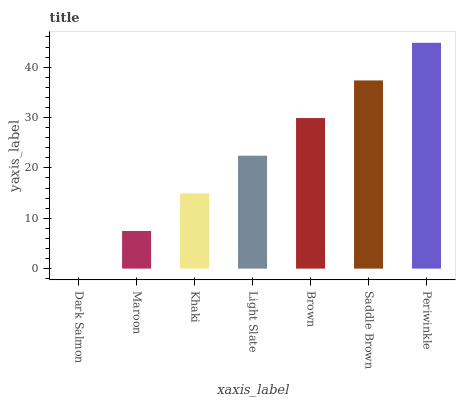Is Maroon the minimum?
Answer yes or no. No. Is Maroon the maximum?
Answer yes or no. No. Is Maroon greater than Dark Salmon?
Answer yes or no. Yes. Is Dark Salmon less than Maroon?
Answer yes or no. Yes. Is Dark Salmon greater than Maroon?
Answer yes or no. No. Is Maroon less than Dark Salmon?
Answer yes or no. No. Is Light Slate the high median?
Answer yes or no. Yes. Is Light Slate the low median?
Answer yes or no. Yes. Is Saddle Brown the high median?
Answer yes or no. No. Is Brown the low median?
Answer yes or no. No. 